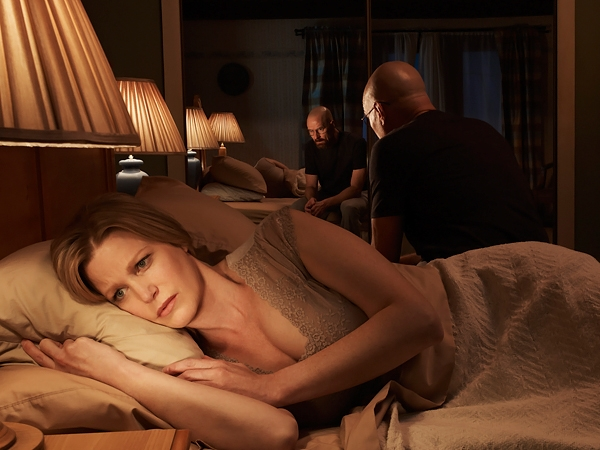Who are the men in the background and what might they be discussing? The men in the background seem engaged in a serious discussion, possibly about a situation that directly affects the woman. The seated man's introspective posture and the other's stance near the window, gazing outside, suggest they might be discussing matters of security, personal safety, or making critical decisions that impact their broader environment. 